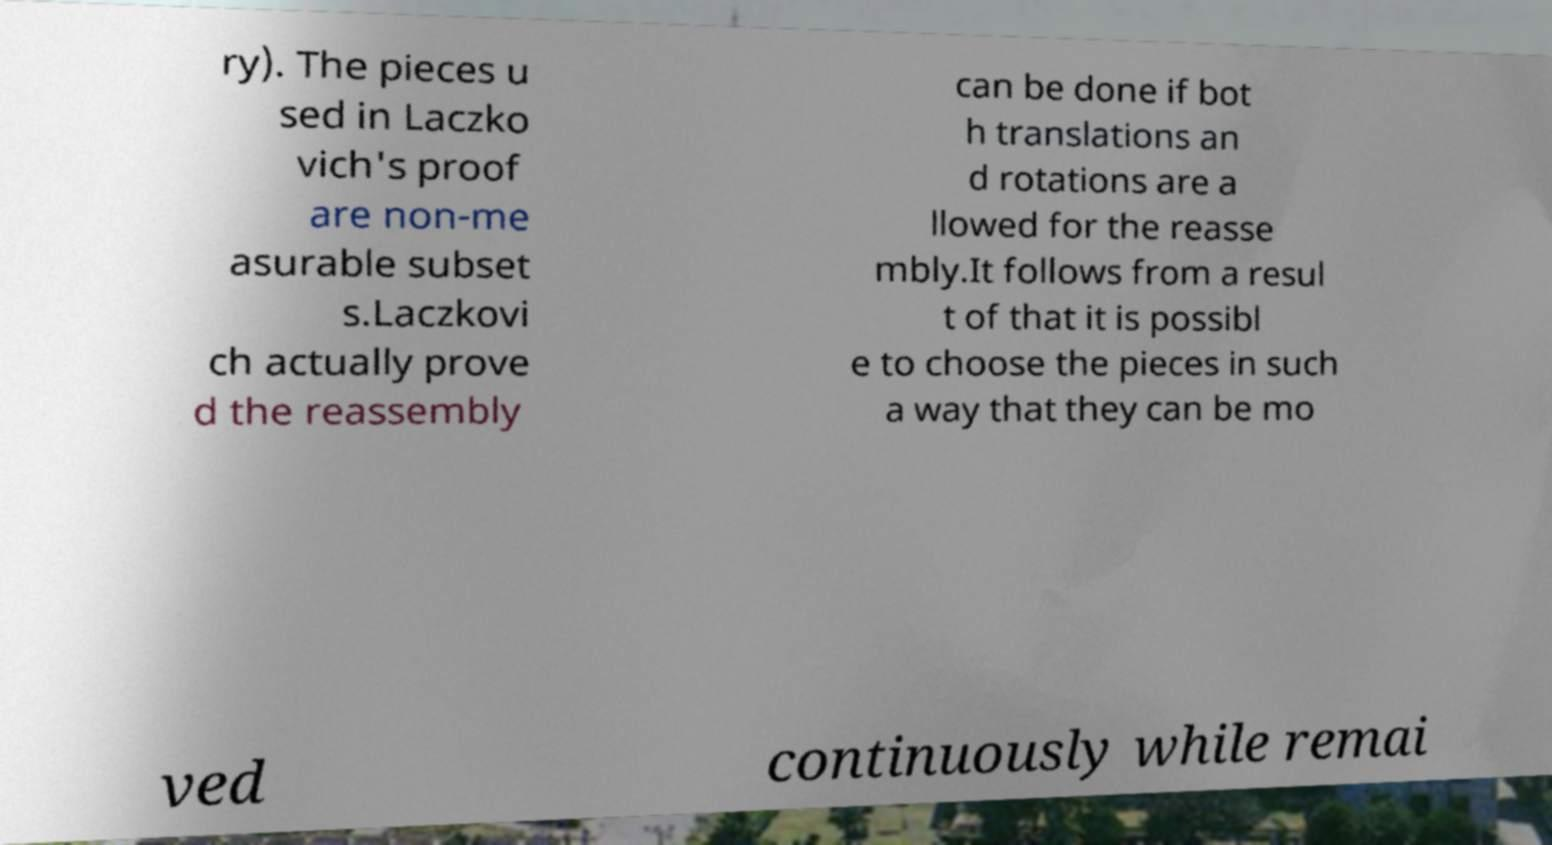Could you assist in decoding the text presented in this image and type it out clearly? ry). The pieces u sed in Laczko vich's proof are non-me asurable subset s.Laczkovi ch actually prove d the reassembly can be done if bot h translations an d rotations are a llowed for the reasse mbly.It follows from a resul t of that it is possibl e to choose the pieces in such a way that they can be mo ved continuously while remai 